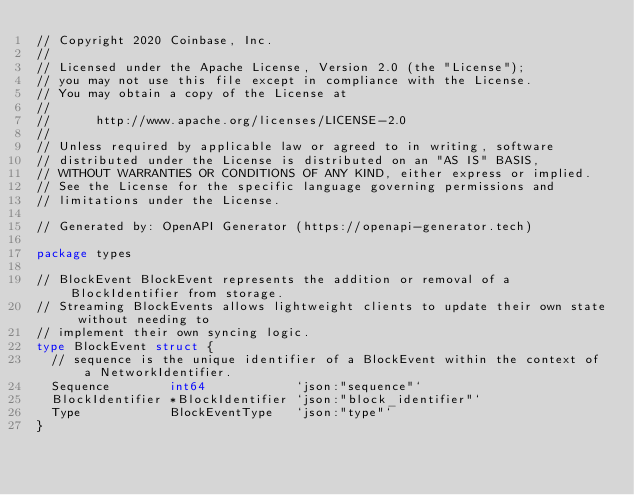Convert code to text. <code><loc_0><loc_0><loc_500><loc_500><_Go_>// Copyright 2020 Coinbase, Inc.
//
// Licensed under the Apache License, Version 2.0 (the "License");
// you may not use this file except in compliance with the License.
// You may obtain a copy of the License at
//
//      http://www.apache.org/licenses/LICENSE-2.0
//
// Unless required by applicable law or agreed to in writing, software
// distributed under the License is distributed on an "AS IS" BASIS,
// WITHOUT WARRANTIES OR CONDITIONS OF ANY KIND, either express or implied.
// See the License for the specific language governing permissions and
// limitations under the License.

// Generated by: OpenAPI Generator (https://openapi-generator.tech)

package types

// BlockEvent BlockEvent represents the addition or removal of a BlockIdentifier from storage.
// Streaming BlockEvents allows lightweight clients to update their own state without needing to
// implement their own syncing logic.
type BlockEvent struct {
	// sequence is the unique identifier of a BlockEvent within the context of a NetworkIdentifier.
	Sequence        int64            `json:"sequence"`
	BlockIdentifier *BlockIdentifier `json:"block_identifier"`
	Type            BlockEventType   `json:"type"`
}
</code> 